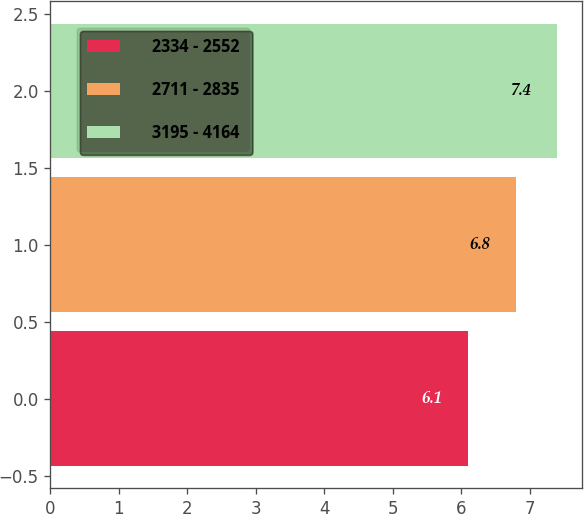Convert chart to OTSL. <chart><loc_0><loc_0><loc_500><loc_500><bar_chart><fcel>2334 - 2552<fcel>2711 - 2835<fcel>3195 - 4164<nl><fcel>6.1<fcel>6.8<fcel>7.4<nl></chart> 